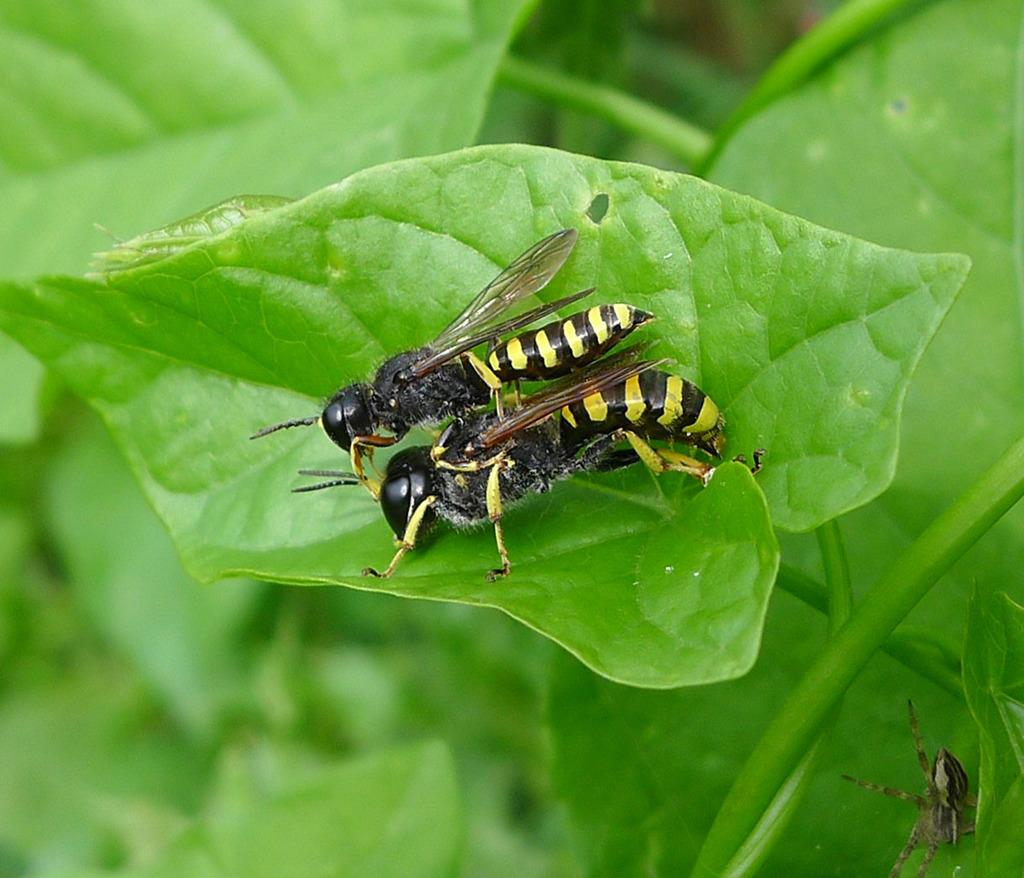What insects can be seen in the image? There are bees on a leaf in the image. Where are the bees located in the image? The bees are in the center of the image. What other creature can be seen in the image? There is a spider at the bottom of the image. What type of wish can be granted by the deer in the image? There is no deer present in the image, so no wishes can be granted. What tool is being used by the bees to gather nectar in the image? Bees do not use tools like a rake to gather nectar; they use their mouthparts and legs. 